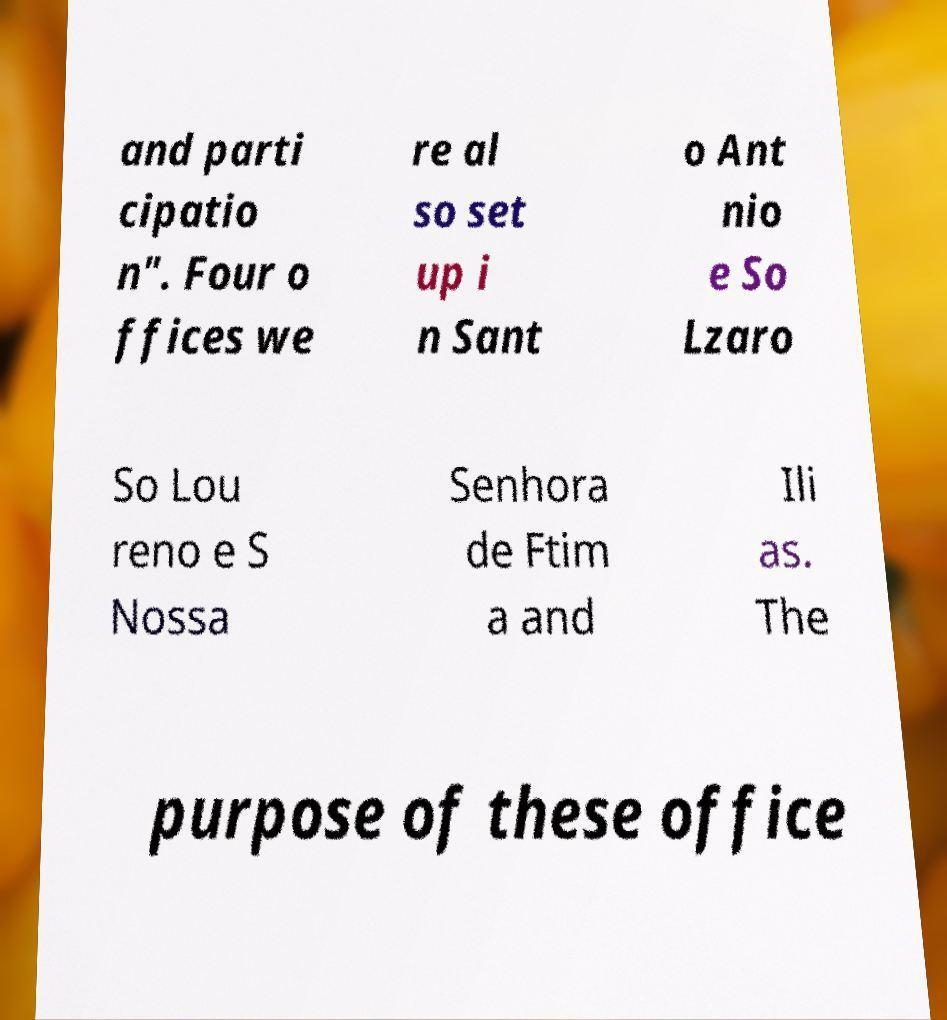What messages or text are displayed in this image? I need them in a readable, typed format. and parti cipatio n". Four o ffices we re al so set up i n Sant o Ant nio e So Lzaro So Lou reno e S Nossa Senhora de Ftim a and Ili as. The purpose of these office 